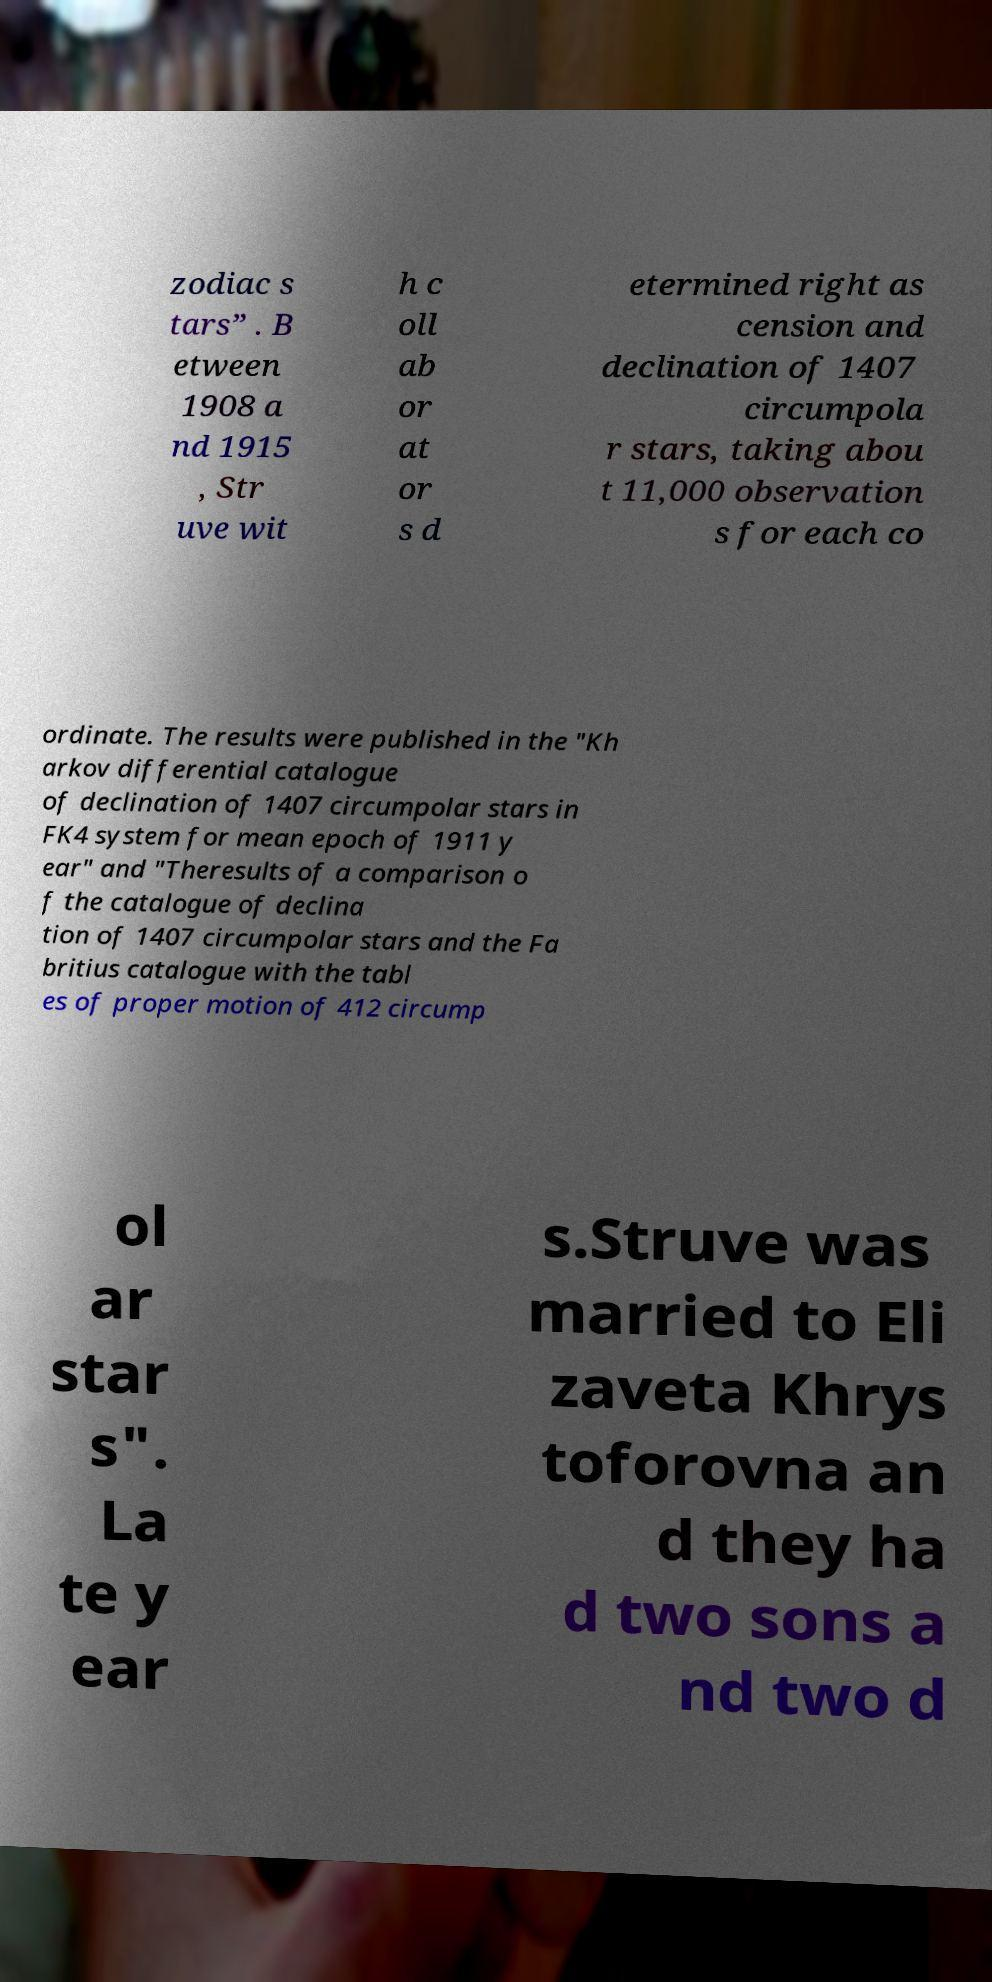I need the written content from this picture converted into text. Can you do that? zodiac s tars” . B etween 1908 a nd 1915 , Str uve wit h c oll ab or at or s d etermined right as cension and declination of 1407 circumpola r stars, taking abou t 11,000 observation s for each co ordinate. The results were published in the "Kh arkov differential catalogue of declination of 1407 circumpolar stars in FK4 system for mean epoch of 1911 y ear" and "Theresults of a comparison o f the catalogue of declina tion of 1407 circumpolar stars and the Fa britius catalogue with the tabl es of proper motion of 412 circump ol ar star s". La te y ear s.Struve was married to Eli zaveta Khrys toforovna an d they ha d two sons a nd two d 